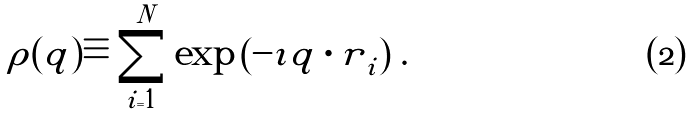<formula> <loc_0><loc_0><loc_500><loc_500>\rho ( q ) \equiv \sum _ { i = 1 } ^ { N } \exp \left ( - \imath { q \cdot r } _ { i } \right ) \, .</formula> 